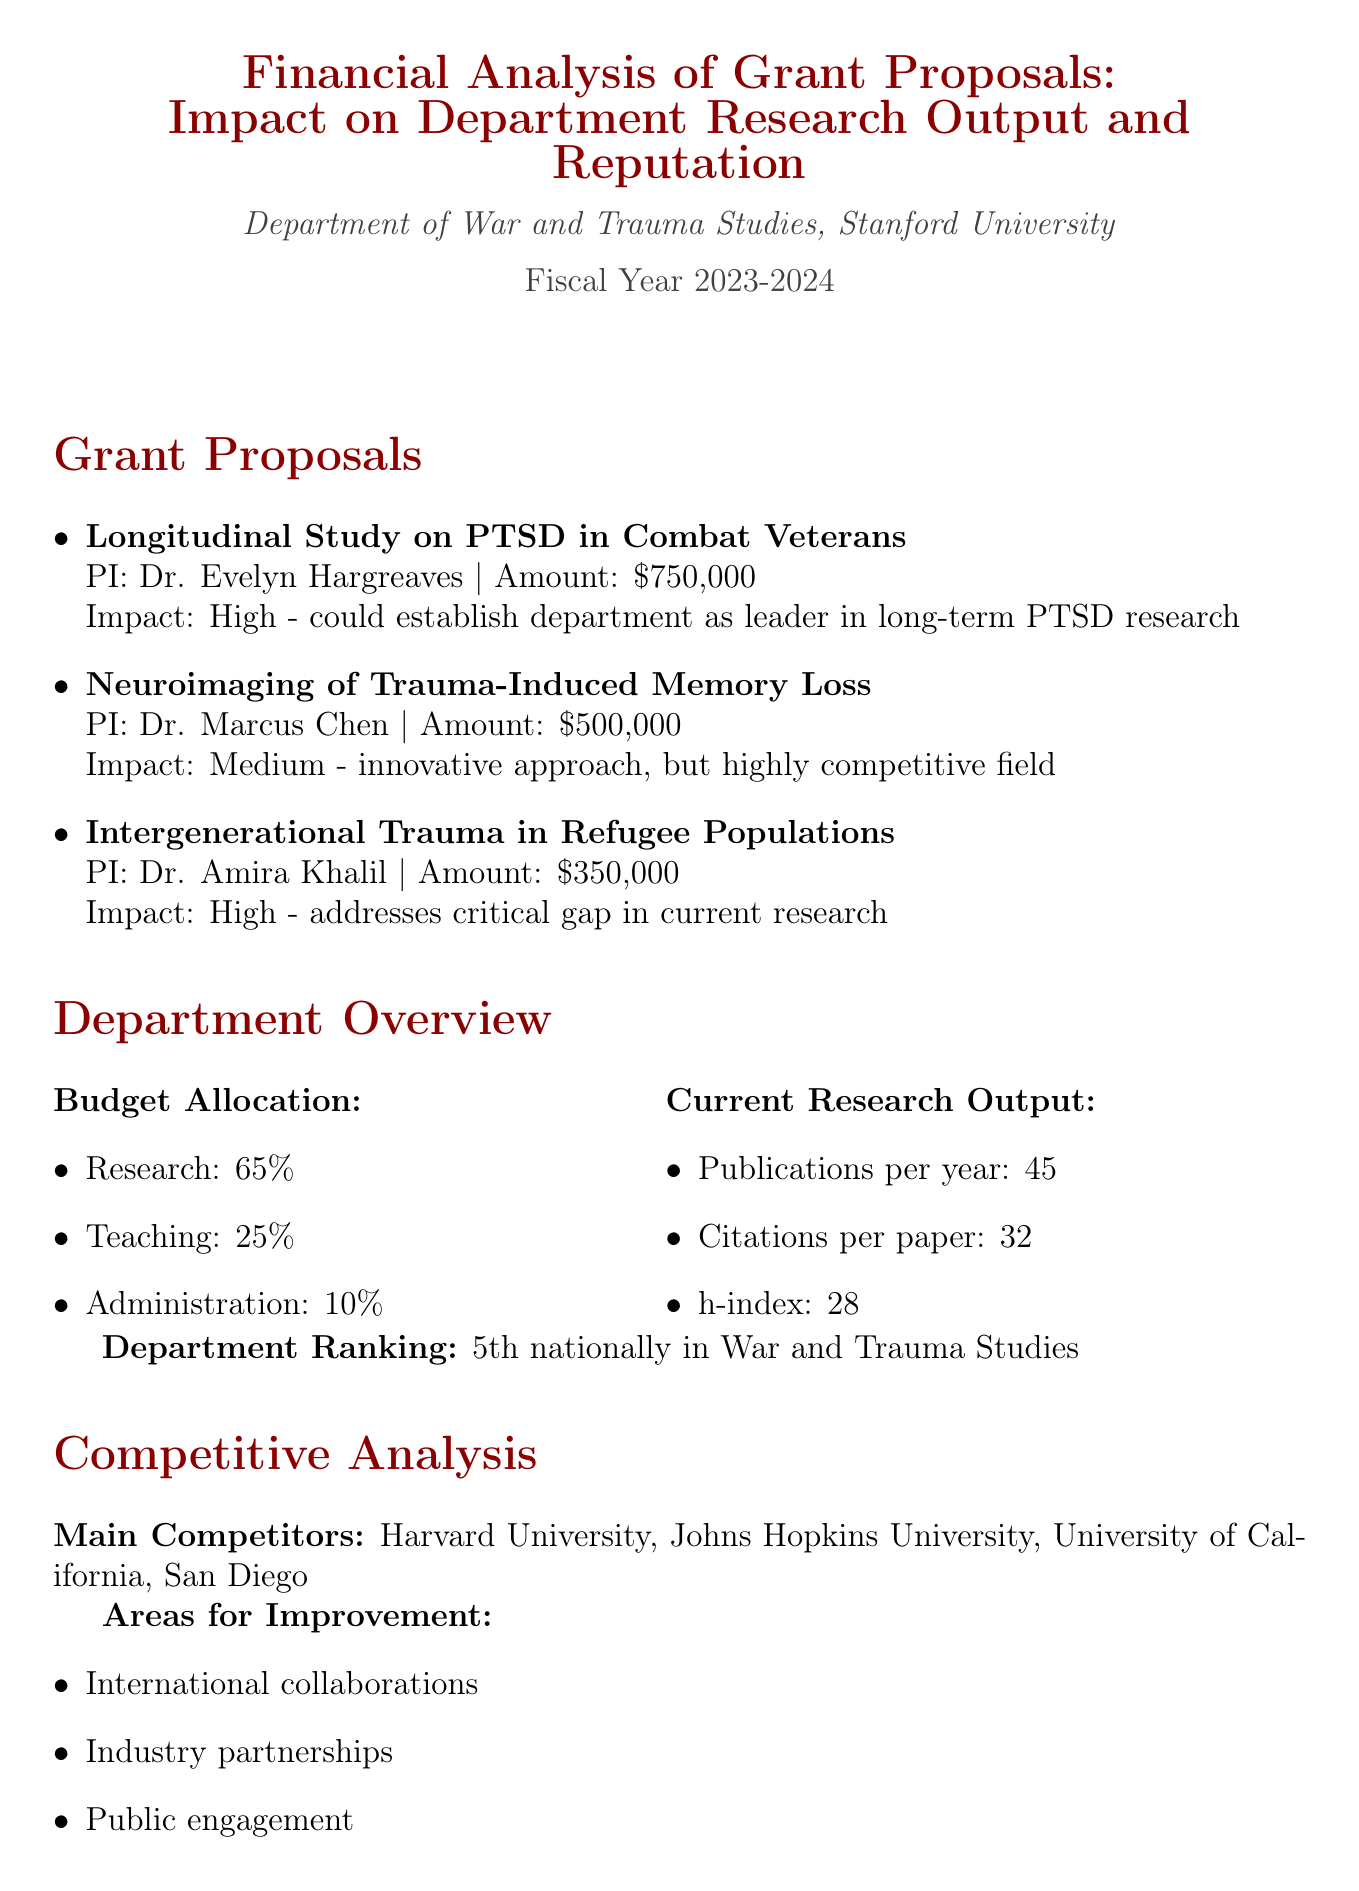What is the title of the report? The title is provided at the beginning of the document, summarizing its purpose.
Answer: Financial Analysis of Grant Proposals: Impact on Department Research Output and Reputation Who is the principal investigator for the proposal titled "Longitudinal Study on PTSD in Combat Veterans"? The document lists the principal investigators alongside each proposal title.
Answer: Dr. Evelyn Hargreaves What is the requested amount for the "Neuroimaging of Trauma-Induced Memory Loss" proposal? The requested amounts for each proposal are indicated in the grant proposals section.
Answer: $500,000 What is the current h-index of the department? This value reflects the department's overall research impact as stated in the current research output section.
Answer: 28 Which proposal is recommended to be prioritized for its potential to establish a new research niche? The recommendations section clearly outlines the priority for the proposals based on their impact.
Answer: Dr. Khalil's proposal How much of the department’s budget is allocated to research? The budget allocation section details the percentage allocated to different areas.
Answer: 65% What is one area for improvement identified in the competitive analysis? The competitive analysis section lists specific areas needing enhancement for the department’s competitiveness.
Answer: International collaborations What is the department's ranking nationally in War and Trauma Studies? This information summarizing the department’s competitive standing is provided in the overview.
Answer: 5th nationally 